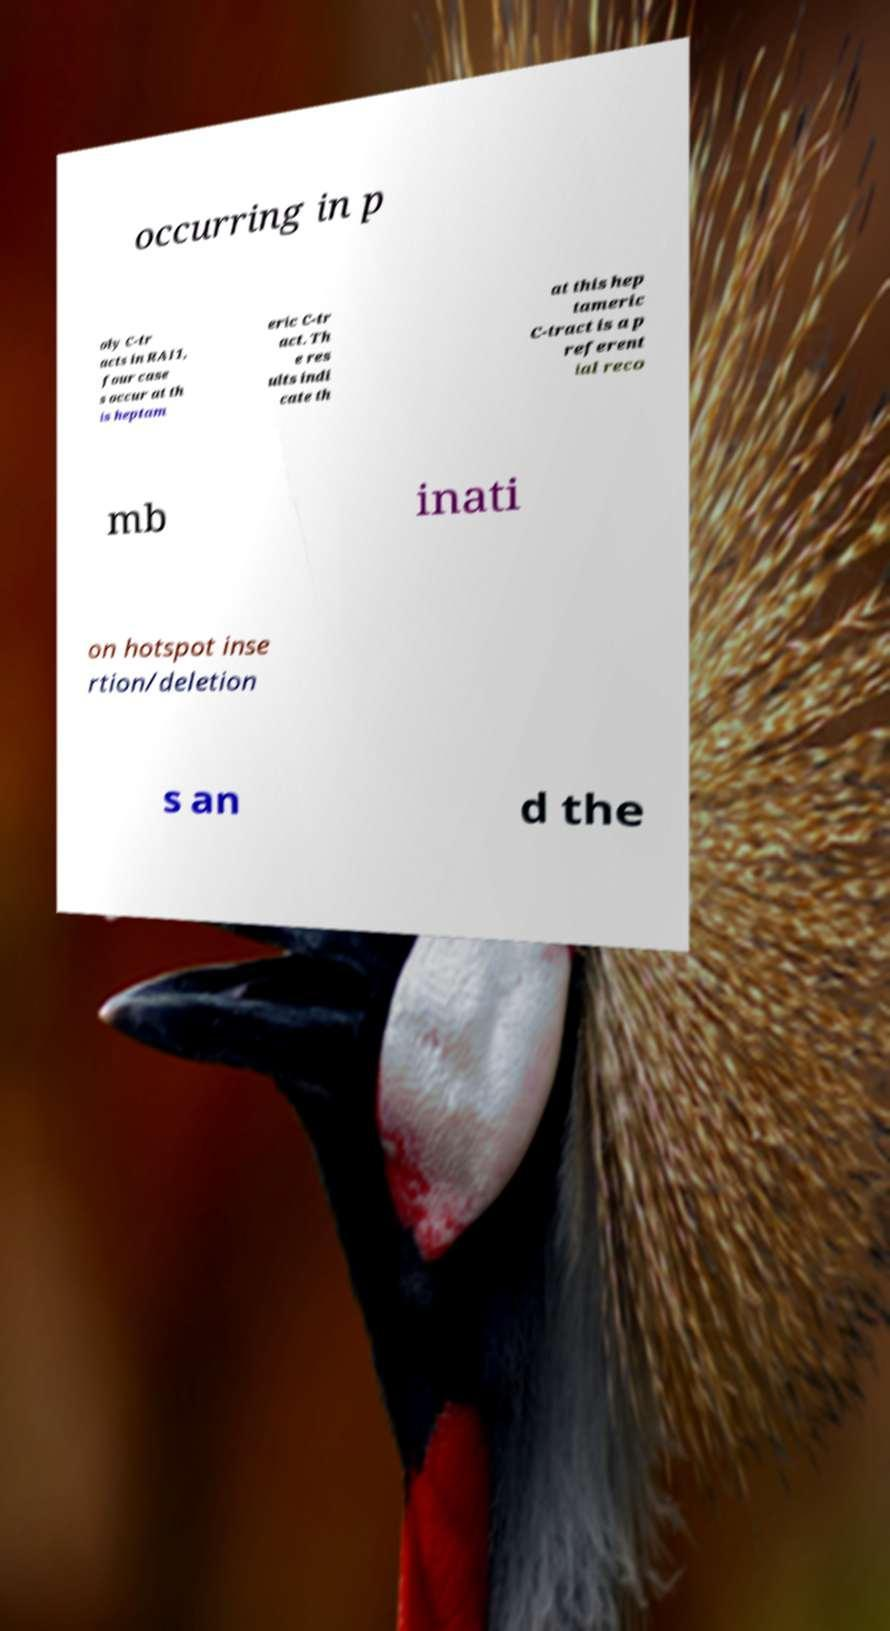For documentation purposes, I need the text within this image transcribed. Could you provide that? occurring in p oly C-tr acts in RAI1, four case s occur at th is heptam eric C-tr act. Th e res ults indi cate th at this hep tameric C-tract is a p referent ial reco mb inati on hotspot inse rtion/deletion s an d the 